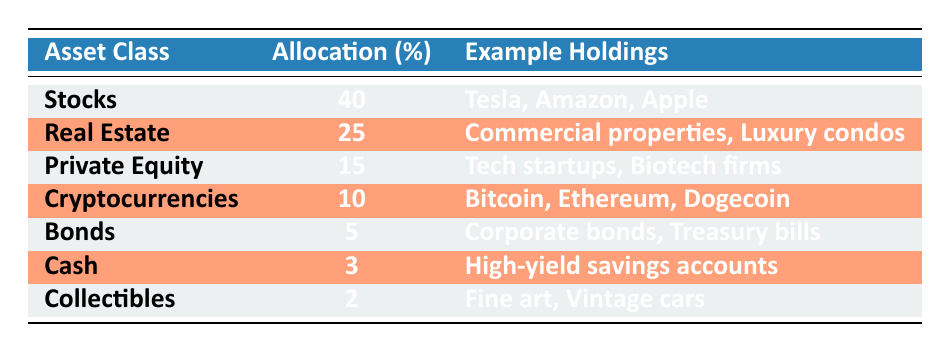What is the largest asset class in the investment portfolio? The largest asset class is Stocks, which has an allocation of 40%.
Answer: Stocks What percentage of the investment portfolio is allocated to Real Estate? Real Estate has an allocation of 25% in the investment portfolio.
Answer: 25% Are Collectibles part of the investment portfolio? Yes, Collectibles are included in the investment portfolio with an allocation of 2%.
Answer: Yes What is the combined allocation of Private Equity and Cryptocurrencies? Private Equity has an allocation of 15% and Cryptocurrencies have 10%. Adding these gives 15 + 10 = 25%.
Answer: 25% Which asset class has the smallest allocation? The asset class with the smallest allocation is Cash, which has an allocation of 3%.
Answer: Cash If Stocks and Real Estate are combined, what percentage of the portfolio do they represent? Stocks have 40% and Real Estate has 25%, so combined they represent 40 + 25 = 65% of the portfolio.
Answer: 65% Is the allocation to Bonds greater than the allocation to Cash? Yes, Bonds have an allocation of 5%, which is greater than Cash's allocation of 3%.
Answer: Yes What fraction of the total portfolio is made up of Cryptocurrencies and Collectibles combined? Cryptocurrencies have an allocation of 10% and Collectibles have 2%, so together they make up 10 + 2 = 12%. To find the fraction of 12% in relation to the total of 100%, it is 12/100 = 0.12 or 12%.
Answer: 12% Which asset classes constitute more than 20% of the total portfolio? The asset classes that constitute more than 20% are Stocks (40%) and Real Estate (25%).
Answer: Stocks and Real Estate What is the total percentage allocated to Cash and Collectibles combined? Cash has 3% and Collectibles have 2%, adding these gives 3 + 2 = 5% total allocation for both.
Answer: 5% 